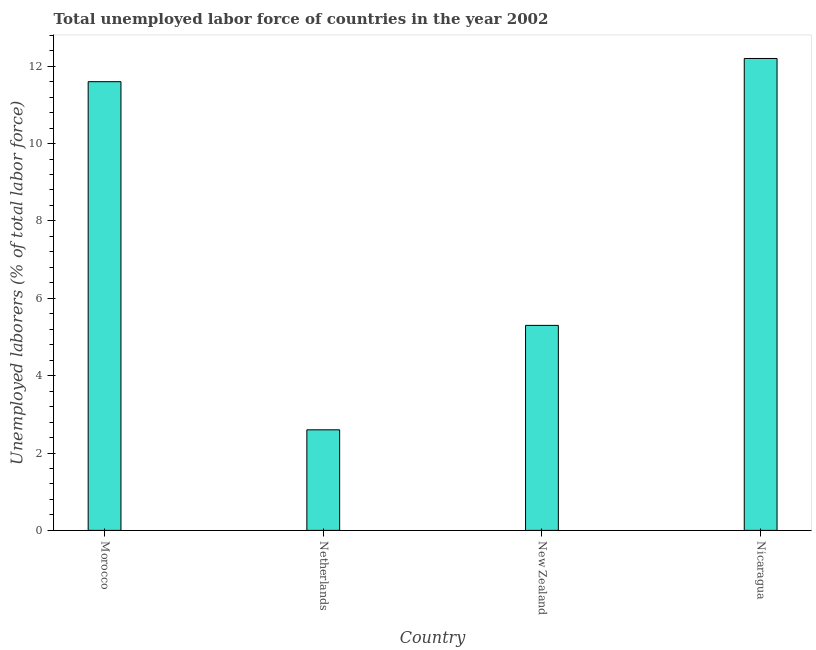Does the graph contain grids?
Keep it short and to the point. No. What is the title of the graph?
Make the answer very short. Total unemployed labor force of countries in the year 2002. What is the label or title of the Y-axis?
Your response must be concise. Unemployed laborers (% of total labor force). What is the total unemployed labour force in Nicaragua?
Provide a short and direct response. 12.2. Across all countries, what is the maximum total unemployed labour force?
Give a very brief answer. 12.2. Across all countries, what is the minimum total unemployed labour force?
Offer a terse response. 2.6. In which country was the total unemployed labour force maximum?
Ensure brevity in your answer.  Nicaragua. In which country was the total unemployed labour force minimum?
Keep it short and to the point. Netherlands. What is the sum of the total unemployed labour force?
Your response must be concise. 31.7. What is the average total unemployed labour force per country?
Provide a short and direct response. 7.92. What is the median total unemployed labour force?
Provide a succinct answer. 8.45. What is the ratio of the total unemployed labour force in Netherlands to that in New Zealand?
Your response must be concise. 0.49. Is the total unemployed labour force in Morocco less than that in New Zealand?
Your answer should be very brief. No. In how many countries, is the total unemployed labour force greater than the average total unemployed labour force taken over all countries?
Ensure brevity in your answer.  2. How many bars are there?
Provide a short and direct response. 4. What is the difference between two consecutive major ticks on the Y-axis?
Provide a short and direct response. 2. Are the values on the major ticks of Y-axis written in scientific E-notation?
Your response must be concise. No. What is the Unemployed laborers (% of total labor force) of Morocco?
Your response must be concise. 11.6. What is the Unemployed laborers (% of total labor force) of Netherlands?
Provide a short and direct response. 2.6. What is the Unemployed laborers (% of total labor force) of New Zealand?
Keep it short and to the point. 5.3. What is the Unemployed laborers (% of total labor force) in Nicaragua?
Give a very brief answer. 12.2. What is the difference between the Unemployed laborers (% of total labor force) in Morocco and Netherlands?
Your answer should be very brief. 9. What is the difference between the Unemployed laborers (% of total labor force) in New Zealand and Nicaragua?
Your answer should be compact. -6.9. What is the ratio of the Unemployed laborers (% of total labor force) in Morocco to that in Netherlands?
Offer a terse response. 4.46. What is the ratio of the Unemployed laborers (% of total labor force) in Morocco to that in New Zealand?
Your answer should be very brief. 2.19. What is the ratio of the Unemployed laborers (% of total labor force) in Morocco to that in Nicaragua?
Your response must be concise. 0.95. What is the ratio of the Unemployed laborers (% of total labor force) in Netherlands to that in New Zealand?
Your answer should be very brief. 0.49. What is the ratio of the Unemployed laborers (% of total labor force) in Netherlands to that in Nicaragua?
Offer a very short reply. 0.21. What is the ratio of the Unemployed laborers (% of total labor force) in New Zealand to that in Nicaragua?
Make the answer very short. 0.43. 